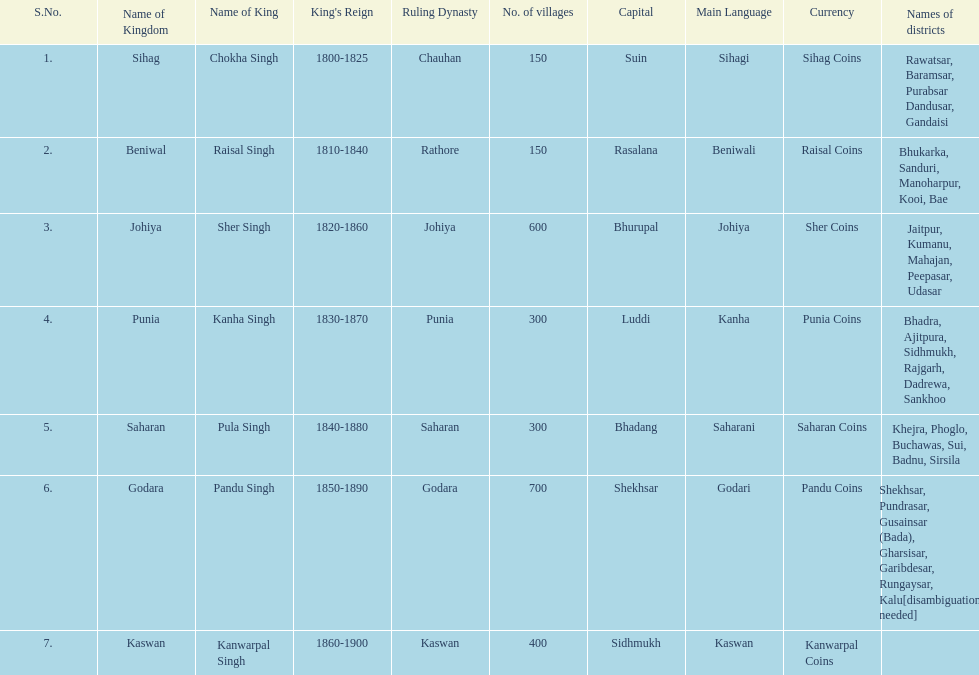How many kingdoms are listed? 7. Could you help me parse every detail presented in this table? {'header': ['S.No.', 'Name of Kingdom', 'Name of King', "King's Reign", 'Ruling Dynasty', 'No. of villages', 'Capital', 'Main Language', 'Currency', 'Names of districts'], 'rows': [['1.', 'Sihag', 'Chokha Singh', '1800-1825', 'Chauhan', '150', 'Suin', 'Sihagi', 'Sihag Coins', 'Rawatsar, Baramsar, Purabsar Dandusar, Gandaisi'], ['2.', 'Beniwal', 'Raisal Singh', '1810-1840', 'Rathore', '150', 'Rasalana', 'Beniwali', 'Raisal Coins', 'Bhukarka, Sanduri, Manoharpur, Kooi, Bae'], ['3.', 'Johiya', 'Sher Singh', '1820-1860', 'Johiya', '600', 'Bhurupal', 'Johiya', 'Sher Coins', 'Jaitpur, Kumanu, Mahajan, Peepasar, Udasar'], ['4.', 'Punia', 'Kanha Singh', '1830-1870', 'Punia', '300', 'Luddi', 'Kanha', 'Punia Coins', 'Bhadra, Ajitpura, Sidhmukh, Rajgarh, Dadrewa, Sankhoo'], ['5.', 'Saharan', 'Pula Singh', '1840-1880', 'Saharan', '300', 'Bhadang', 'Saharani', 'Saharan Coins', 'Khejra, Phoglo, Buchawas, Sui, Badnu, Sirsila'], ['6.', 'Godara', 'Pandu Singh', '1850-1890', 'Godara', '700', 'Shekhsar', 'Godari', 'Pandu Coins', 'Shekhsar, Pundrasar, Gusainsar (Bada), Gharsisar, Garibdesar, Rungaysar, Kalu[disambiguation needed]'], ['7.', 'Kaswan', 'Kanwarpal Singh', '1860-1900', 'Kaswan', '400', 'Sidhmukh', 'Kaswan', 'Kanwarpal Coins', '']]} 